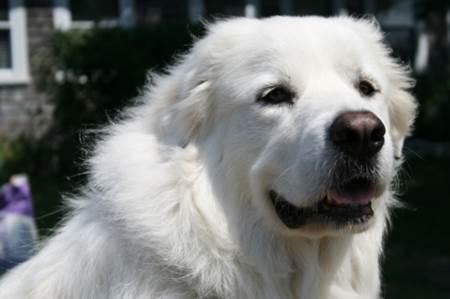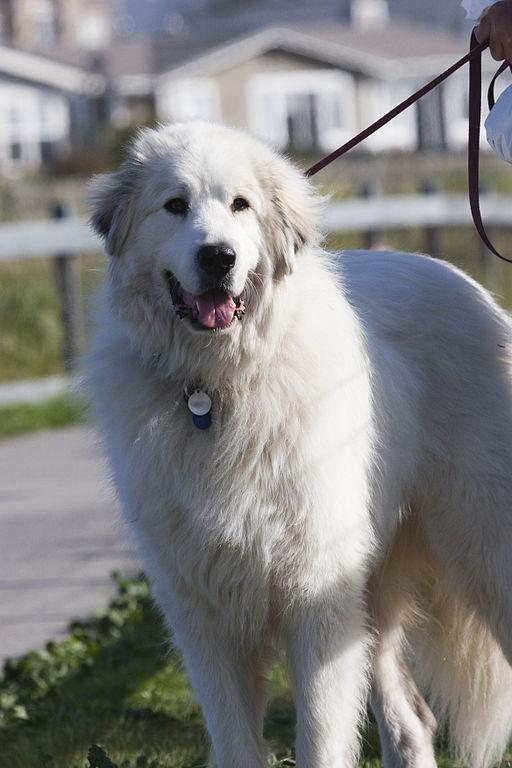The first image is the image on the left, the second image is the image on the right. Assess this claim about the two images: "There is one puppy and one adult dog". Correct or not? Answer yes or no. No. The first image is the image on the left, the second image is the image on the right. Examine the images to the left and right. Is the description "The left image contains one non-standing white puppy, while the right image contains one standing white adult dog." accurate? Answer yes or no. No. 